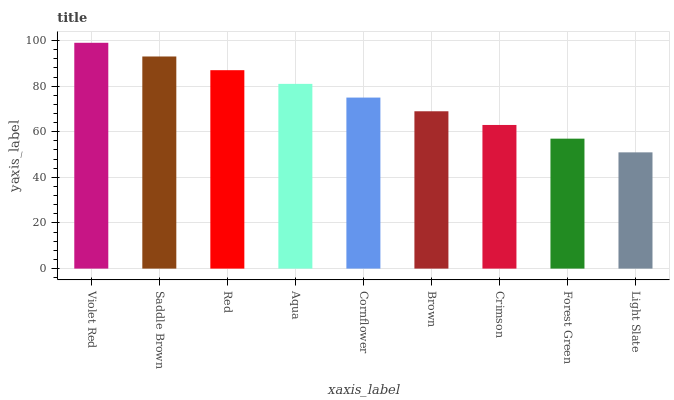Is Saddle Brown the minimum?
Answer yes or no. No. Is Saddle Brown the maximum?
Answer yes or no. No. Is Violet Red greater than Saddle Brown?
Answer yes or no. Yes. Is Saddle Brown less than Violet Red?
Answer yes or no. Yes. Is Saddle Brown greater than Violet Red?
Answer yes or no. No. Is Violet Red less than Saddle Brown?
Answer yes or no. No. Is Cornflower the high median?
Answer yes or no. Yes. Is Cornflower the low median?
Answer yes or no. Yes. Is Forest Green the high median?
Answer yes or no. No. Is Red the low median?
Answer yes or no. No. 